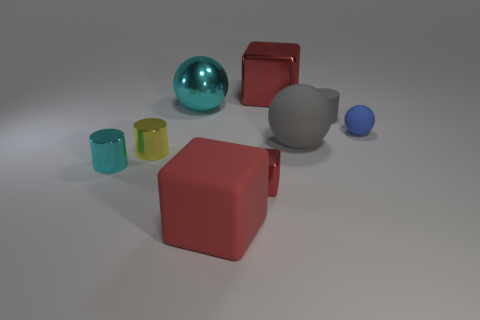Add 1 cubes. How many objects exist? 10 Subtract all cylinders. How many objects are left? 6 Subtract 0 brown spheres. How many objects are left? 9 Subtract all big shiny balls. Subtract all large red rubber objects. How many objects are left? 7 Add 5 yellow cylinders. How many yellow cylinders are left? 6 Add 2 large gray rubber spheres. How many large gray rubber spheres exist? 3 